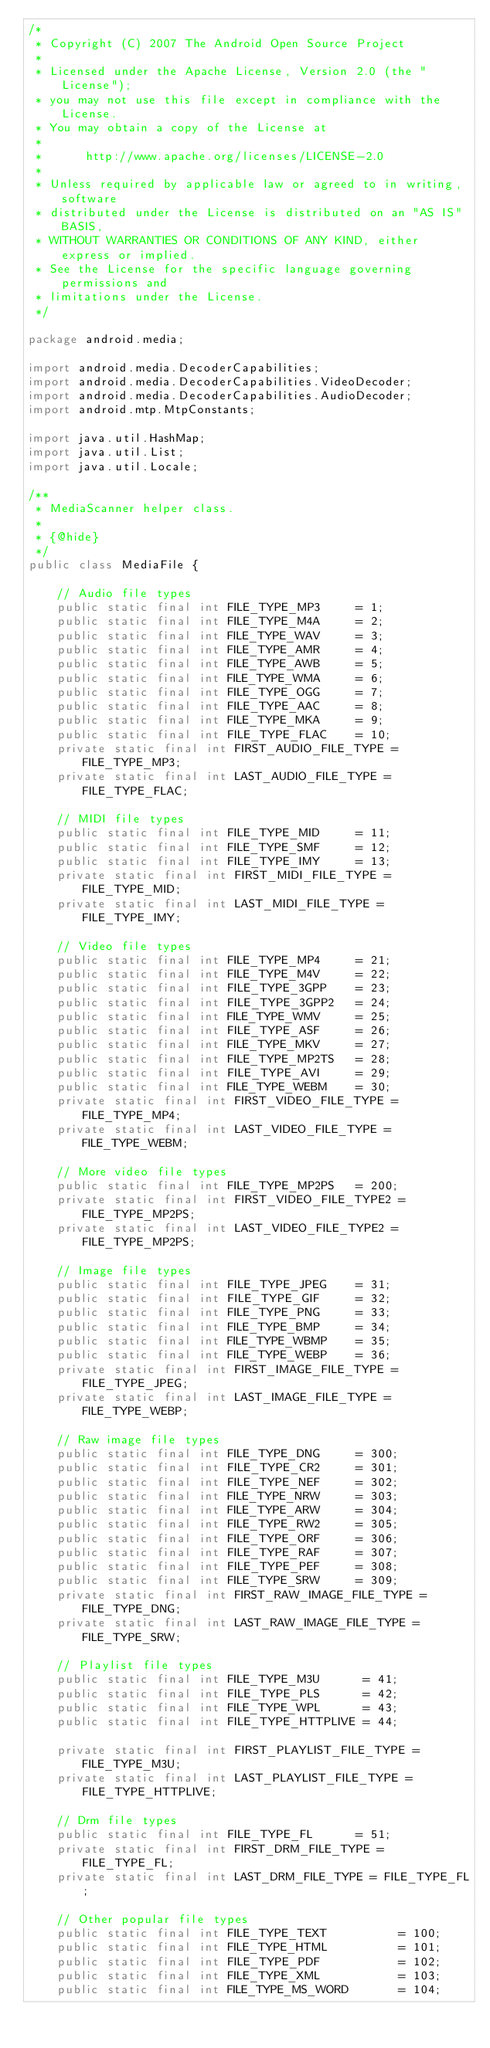<code> <loc_0><loc_0><loc_500><loc_500><_Java_>/*
 * Copyright (C) 2007 The Android Open Source Project
 *
 * Licensed under the Apache License, Version 2.0 (the "License");
 * you may not use this file except in compliance with the License.
 * You may obtain a copy of the License at
 *
 *      http://www.apache.org/licenses/LICENSE-2.0
 *
 * Unless required by applicable law or agreed to in writing, software
 * distributed under the License is distributed on an "AS IS" BASIS,
 * WITHOUT WARRANTIES OR CONDITIONS OF ANY KIND, either express or implied.
 * See the License for the specific language governing permissions and
 * limitations under the License.
 */

package android.media;

import android.media.DecoderCapabilities;
import android.media.DecoderCapabilities.VideoDecoder;
import android.media.DecoderCapabilities.AudioDecoder;
import android.mtp.MtpConstants;

import java.util.HashMap;
import java.util.List;
import java.util.Locale;

/**
 * MediaScanner helper class.
 *
 * {@hide}
 */
public class MediaFile {

    // Audio file types
    public static final int FILE_TYPE_MP3     = 1;
    public static final int FILE_TYPE_M4A     = 2;
    public static final int FILE_TYPE_WAV     = 3;
    public static final int FILE_TYPE_AMR     = 4;
    public static final int FILE_TYPE_AWB     = 5;
    public static final int FILE_TYPE_WMA     = 6;
    public static final int FILE_TYPE_OGG     = 7;
    public static final int FILE_TYPE_AAC     = 8;
    public static final int FILE_TYPE_MKA     = 9;
    public static final int FILE_TYPE_FLAC    = 10;
    private static final int FIRST_AUDIO_FILE_TYPE = FILE_TYPE_MP3;
    private static final int LAST_AUDIO_FILE_TYPE = FILE_TYPE_FLAC;

    // MIDI file types
    public static final int FILE_TYPE_MID     = 11;
    public static final int FILE_TYPE_SMF     = 12;
    public static final int FILE_TYPE_IMY     = 13;
    private static final int FIRST_MIDI_FILE_TYPE = FILE_TYPE_MID;
    private static final int LAST_MIDI_FILE_TYPE = FILE_TYPE_IMY;

    // Video file types
    public static final int FILE_TYPE_MP4     = 21;
    public static final int FILE_TYPE_M4V     = 22;
    public static final int FILE_TYPE_3GPP    = 23;
    public static final int FILE_TYPE_3GPP2   = 24;
    public static final int FILE_TYPE_WMV     = 25;
    public static final int FILE_TYPE_ASF     = 26;
    public static final int FILE_TYPE_MKV     = 27;
    public static final int FILE_TYPE_MP2TS   = 28;
    public static final int FILE_TYPE_AVI     = 29;
    public static final int FILE_TYPE_WEBM    = 30;
    private static final int FIRST_VIDEO_FILE_TYPE = FILE_TYPE_MP4;
    private static final int LAST_VIDEO_FILE_TYPE = FILE_TYPE_WEBM;

    // More video file types
    public static final int FILE_TYPE_MP2PS   = 200;
    private static final int FIRST_VIDEO_FILE_TYPE2 = FILE_TYPE_MP2PS;
    private static final int LAST_VIDEO_FILE_TYPE2 = FILE_TYPE_MP2PS;

    // Image file types
    public static final int FILE_TYPE_JPEG    = 31;
    public static final int FILE_TYPE_GIF     = 32;
    public static final int FILE_TYPE_PNG     = 33;
    public static final int FILE_TYPE_BMP     = 34;
    public static final int FILE_TYPE_WBMP    = 35;
    public static final int FILE_TYPE_WEBP    = 36;
    private static final int FIRST_IMAGE_FILE_TYPE = FILE_TYPE_JPEG;
    private static final int LAST_IMAGE_FILE_TYPE = FILE_TYPE_WEBP;

    // Raw image file types
    public static final int FILE_TYPE_DNG     = 300;
    public static final int FILE_TYPE_CR2     = 301;
    public static final int FILE_TYPE_NEF     = 302;
    public static final int FILE_TYPE_NRW     = 303;
    public static final int FILE_TYPE_ARW     = 304;
    public static final int FILE_TYPE_RW2     = 305;
    public static final int FILE_TYPE_ORF     = 306;
    public static final int FILE_TYPE_RAF     = 307;
    public static final int FILE_TYPE_PEF     = 308;
    public static final int FILE_TYPE_SRW     = 309;
    private static final int FIRST_RAW_IMAGE_FILE_TYPE = FILE_TYPE_DNG;
    private static final int LAST_RAW_IMAGE_FILE_TYPE = FILE_TYPE_SRW;

    // Playlist file types
    public static final int FILE_TYPE_M3U      = 41;
    public static final int FILE_TYPE_PLS      = 42;
    public static final int FILE_TYPE_WPL      = 43;
    public static final int FILE_TYPE_HTTPLIVE = 44;

    private static final int FIRST_PLAYLIST_FILE_TYPE = FILE_TYPE_M3U;
    private static final int LAST_PLAYLIST_FILE_TYPE = FILE_TYPE_HTTPLIVE;

    // Drm file types
    public static final int FILE_TYPE_FL      = 51;
    private static final int FIRST_DRM_FILE_TYPE = FILE_TYPE_FL;
    private static final int LAST_DRM_FILE_TYPE = FILE_TYPE_FL;

    // Other popular file types
    public static final int FILE_TYPE_TEXT          = 100;
    public static final int FILE_TYPE_HTML          = 101;
    public static final int FILE_TYPE_PDF           = 102;
    public static final int FILE_TYPE_XML           = 103;
    public static final int FILE_TYPE_MS_WORD       = 104;</code> 